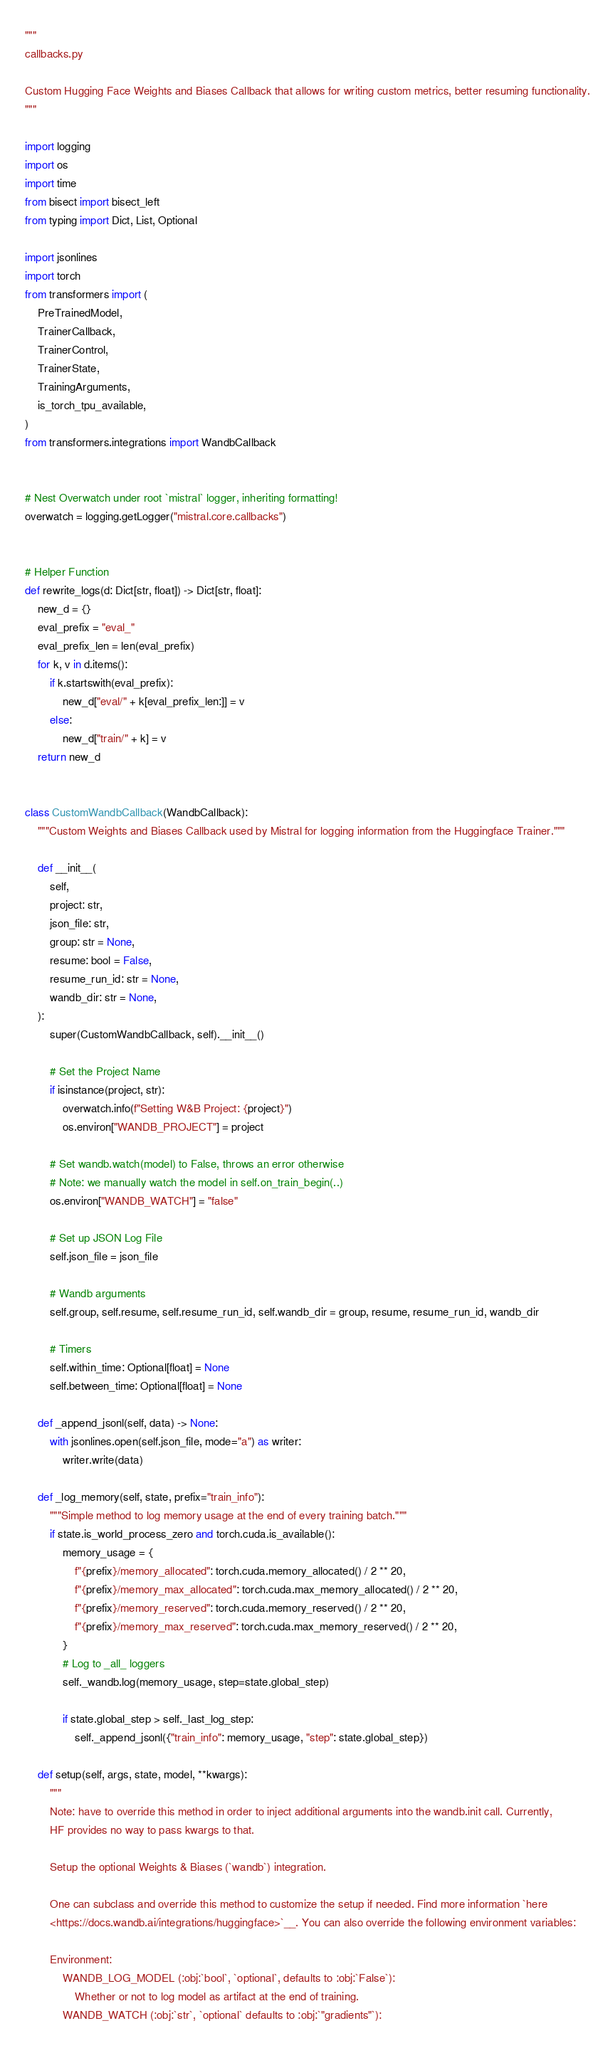<code> <loc_0><loc_0><loc_500><loc_500><_Python_>"""
callbacks.py

Custom Hugging Face Weights and Biases Callback that allows for writing custom metrics, better resuming functionality.
"""

import logging
import os
import time
from bisect import bisect_left
from typing import Dict, List, Optional

import jsonlines
import torch
from transformers import (
    PreTrainedModel,
    TrainerCallback,
    TrainerControl,
    TrainerState,
    TrainingArguments,
    is_torch_tpu_available,
)
from transformers.integrations import WandbCallback


# Nest Overwatch under root `mistral` logger, inheriting formatting!
overwatch = logging.getLogger("mistral.core.callbacks")


# Helper Function
def rewrite_logs(d: Dict[str, float]) -> Dict[str, float]:
    new_d = {}
    eval_prefix = "eval_"
    eval_prefix_len = len(eval_prefix)
    for k, v in d.items():
        if k.startswith(eval_prefix):
            new_d["eval/" + k[eval_prefix_len:]] = v
        else:
            new_d["train/" + k] = v
    return new_d


class CustomWandbCallback(WandbCallback):
    """Custom Weights and Biases Callback used by Mistral for logging information from the Huggingface Trainer."""

    def __init__(
        self,
        project: str,
        json_file: str,
        group: str = None,
        resume: bool = False,
        resume_run_id: str = None,
        wandb_dir: str = None,
    ):
        super(CustomWandbCallback, self).__init__()

        # Set the Project Name
        if isinstance(project, str):
            overwatch.info(f"Setting W&B Project: {project}")
            os.environ["WANDB_PROJECT"] = project

        # Set wandb.watch(model) to False, throws an error otherwise
        # Note: we manually watch the model in self.on_train_begin(..)
        os.environ["WANDB_WATCH"] = "false"

        # Set up JSON Log File
        self.json_file = json_file

        # Wandb arguments
        self.group, self.resume, self.resume_run_id, self.wandb_dir = group, resume, resume_run_id, wandb_dir

        # Timers
        self.within_time: Optional[float] = None
        self.between_time: Optional[float] = None

    def _append_jsonl(self, data) -> None:
        with jsonlines.open(self.json_file, mode="a") as writer:
            writer.write(data)

    def _log_memory(self, state, prefix="train_info"):
        """Simple method to log memory usage at the end of every training batch."""
        if state.is_world_process_zero and torch.cuda.is_available():
            memory_usage = {
                f"{prefix}/memory_allocated": torch.cuda.memory_allocated() / 2 ** 20,
                f"{prefix}/memory_max_allocated": torch.cuda.max_memory_allocated() / 2 ** 20,
                f"{prefix}/memory_reserved": torch.cuda.memory_reserved() / 2 ** 20,
                f"{prefix}/memory_max_reserved": torch.cuda.max_memory_reserved() / 2 ** 20,
            }
            # Log to _all_ loggers
            self._wandb.log(memory_usage, step=state.global_step)

            if state.global_step > self._last_log_step:
                self._append_jsonl({"train_info": memory_usage, "step": state.global_step})

    def setup(self, args, state, model, **kwargs):
        """
        Note: have to override this method in order to inject additional arguments into the wandb.init call. Currently,
        HF provides no way to pass kwargs to that.

        Setup the optional Weights & Biases (`wandb`) integration.

        One can subclass and override this method to customize the setup if needed. Find more information `here
        <https://docs.wandb.ai/integrations/huggingface>`__. You can also override the following environment variables:

        Environment:
            WANDB_LOG_MODEL (:obj:`bool`, `optional`, defaults to :obj:`False`):
                Whether or not to log model as artifact at the end of training.
            WANDB_WATCH (:obj:`str`, `optional` defaults to :obj:`"gradients"`):</code> 